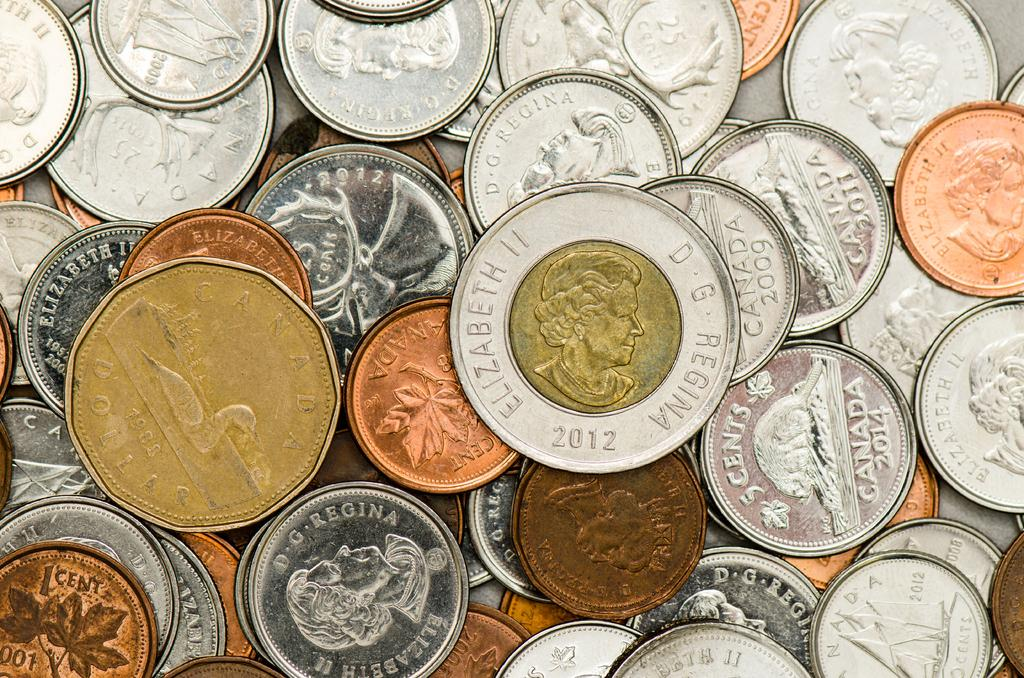<image>
Provide a brief description of the given image. A bunch of different coins with one in the forefront that says Elizabeth II D.G. Regina 2012 